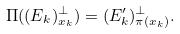<formula> <loc_0><loc_0><loc_500><loc_500>\Pi ( ( E _ { k } ) _ { x _ { k } } ^ { \perp } ) = ( E _ { k } ^ { \prime } ) _ { \pi ( x _ { k } ) } ^ { \perp } .</formula> 